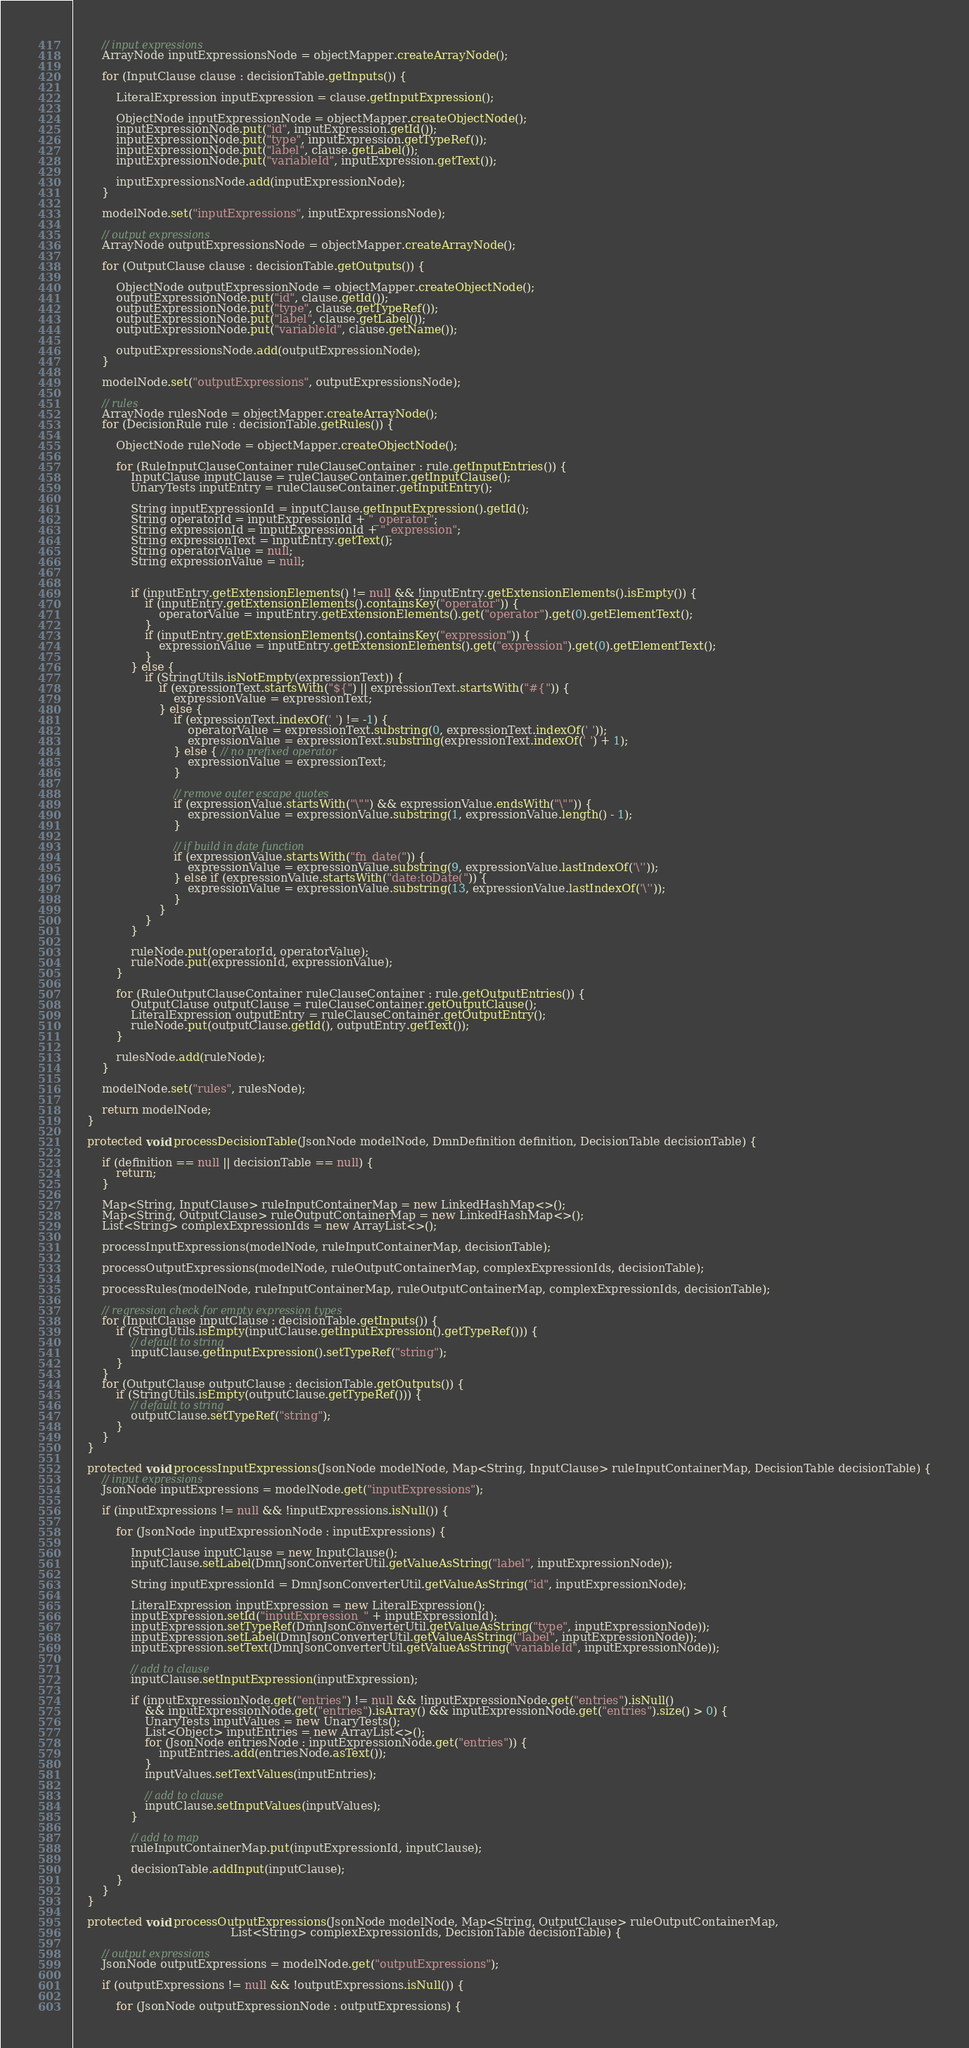<code> <loc_0><loc_0><loc_500><loc_500><_Java_>        // input expressions
        ArrayNode inputExpressionsNode = objectMapper.createArrayNode();

        for (InputClause clause : decisionTable.getInputs()) {

            LiteralExpression inputExpression = clause.getInputExpression();

            ObjectNode inputExpressionNode = objectMapper.createObjectNode();
            inputExpressionNode.put("id", inputExpression.getId());
            inputExpressionNode.put("type", inputExpression.getTypeRef());
            inputExpressionNode.put("label", clause.getLabel());
            inputExpressionNode.put("variableId", inputExpression.getText());

            inputExpressionsNode.add(inputExpressionNode);
        }

        modelNode.set("inputExpressions", inputExpressionsNode);

        // output expressions
        ArrayNode outputExpressionsNode = objectMapper.createArrayNode();

        for (OutputClause clause : decisionTable.getOutputs()) {

            ObjectNode outputExpressionNode = objectMapper.createObjectNode();
            outputExpressionNode.put("id", clause.getId());
            outputExpressionNode.put("type", clause.getTypeRef());
            outputExpressionNode.put("label", clause.getLabel());
            outputExpressionNode.put("variableId", clause.getName());

            outputExpressionsNode.add(outputExpressionNode);
        }

        modelNode.set("outputExpressions", outputExpressionsNode);

        // rules
        ArrayNode rulesNode = objectMapper.createArrayNode();
        for (DecisionRule rule : decisionTable.getRules()) {

            ObjectNode ruleNode = objectMapper.createObjectNode();

            for (RuleInputClauseContainer ruleClauseContainer : rule.getInputEntries()) {
                InputClause inputClause = ruleClauseContainer.getInputClause();
                UnaryTests inputEntry = ruleClauseContainer.getInputEntry();

                String inputExpressionId = inputClause.getInputExpression().getId();
                String operatorId = inputExpressionId + "_operator";
                String expressionId = inputExpressionId + "_expression";
                String expressionText = inputEntry.getText();
                String operatorValue = null;
                String expressionValue = null;


                if (inputEntry.getExtensionElements() != null && !inputEntry.getExtensionElements().isEmpty()) {
                    if (inputEntry.getExtensionElements().containsKey("operator")) {
                        operatorValue = inputEntry.getExtensionElements().get("operator").get(0).getElementText();
                    }
                    if (inputEntry.getExtensionElements().containsKey("expression")) {
                        expressionValue = inputEntry.getExtensionElements().get("expression").get(0).getElementText();
                    }
                } else {
                    if (StringUtils.isNotEmpty(expressionText)) {
                        if (expressionText.startsWith("${") || expressionText.startsWith("#{")) {
                            expressionValue = expressionText;
                        } else {
                            if (expressionText.indexOf(' ') != -1) {
                                operatorValue = expressionText.substring(0, expressionText.indexOf(' '));
                                expressionValue = expressionText.substring(expressionText.indexOf(' ') + 1);
                            } else { // no prefixed operator
                                expressionValue = expressionText;
                            }

                            // remove outer escape quotes
                            if (expressionValue.startsWith("\"") && expressionValue.endsWith("\"")) {
                                expressionValue = expressionValue.substring(1, expressionValue.length() - 1);
                            }

                            // if build in date function
                            if (expressionValue.startsWith("fn_date(")) {
                                expressionValue = expressionValue.substring(9, expressionValue.lastIndexOf('\''));
                            } else if (expressionValue.startsWith("date:toDate(")) {
                                expressionValue = expressionValue.substring(13, expressionValue.lastIndexOf('\''));
                            }
                        }
                    }
                }

                ruleNode.put(operatorId, operatorValue);
                ruleNode.put(expressionId, expressionValue);
            }

            for (RuleOutputClauseContainer ruleClauseContainer : rule.getOutputEntries()) {
                OutputClause outputClause = ruleClauseContainer.getOutputClause();
                LiteralExpression outputEntry = ruleClauseContainer.getOutputEntry();
                ruleNode.put(outputClause.getId(), outputEntry.getText());
            }

            rulesNode.add(ruleNode);
        }

        modelNode.set("rules", rulesNode);

        return modelNode;
    }

    protected void processDecisionTable(JsonNode modelNode, DmnDefinition definition, DecisionTable decisionTable) {

        if (definition == null || decisionTable == null) {
            return;
        }

        Map<String, InputClause> ruleInputContainerMap = new LinkedHashMap<>();
        Map<String, OutputClause> ruleOutputContainerMap = new LinkedHashMap<>();
        List<String> complexExpressionIds = new ArrayList<>();

        processInputExpressions(modelNode, ruleInputContainerMap, decisionTable);

        processOutputExpressions(modelNode, ruleOutputContainerMap, complexExpressionIds, decisionTable);

        processRules(modelNode, ruleInputContainerMap, ruleOutputContainerMap, complexExpressionIds, decisionTable);

        // regression check for empty expression types
        for (InputClause inputClause : decisionTable.getInputs()) {
            if (StringUtils.isEmpty(inputClause.getInputExpression().getTypeRef())) {
                // default to string
                inputClause.getInputExpression().setTypeRef("string");
            }
        }
        for (OutputClause outputClause : decisionTable.getOutputs()) {
            if (StringUtils.isEmpty(outputClause.getTypeRef())) {
                // default to string
                outputClause.setTypeRef("string");
            }
        }
    }

    protected void processInputExpressions(JsonNode modelNode, Map<String, InputClause> ruleInputContainerMap, DecisionTable decisionTable) {
        // input expressions
        JsonNode inputExpressions = modelNode.get("inputExpressions");

        if (inputExpressions != null && !inputExpressions.isNull()) {

            for (JsonNode inputExpressionNode : inputExpressions) {

                InputClause inputClause = new InputClause();
                inputClause.setLabel(DmnJsonConverterUtil.getValueAsString("label", inputExpressionNode));

                String inputExpressionId = DmnJsonConverterUtil.getValueAsString("id", inputExpressionNode);

                LiteralExpression inputExpression = new LiteralExpression();
                inputExpression.setId("inputExpression_" + inputExpressionId);
                inputExpression.setTypeRef(DmnJsonConverterUtil.getValueAsString("type", inputExpressionNode));
                inputExpression.setLabel(DmnJsonConverterUtil.getValueAsString("label", inputExpressionNode));
                inputExpression.setText(DmnJsonConverterUtil.getValueAsString("variableId", inputExpressionNode));

                // add to clause
                inputClause.setInputExpression(inputExpression);

                if (inputExpressionNode.get("entries") != null && !inputExpressionNode.get("entries").isNull()
                    && inputExpressionNode.get("entries").isArray() && inputExpressionNode.get("entries").size() > 0) {
                    UnaryTests inputValues = new UnaryTests();
                    List<Object> inputEntries = new ArrayList<>();
                    for (JsonNode entriesNode : inputExpressionNode.get("entries")) {
                        inputEntries.add(entriesNode.asText());
                    }
                    inputValues.setTextValues(inputEntries);

                    // add to clause
                    inputClause.setInputValues(inputValues);
                }

                // add to map
                ruleInputContainerMap.put(inputExpressionId, inputClause);

                decisionTable.addInput(inputClause);
            }
        }
    }

    protected void processOutputExpressions(JsonNode modelNode, Map<String, OutputClause> ruleOutputContainerMap,
                                            List<String> complexExpressionIds, DecisionTable decisionTable) {

        // output expressions
        JsonNode outputExpressions = modelNode.get("outputExpressions");

        if (outputExpressions != null && !outputExpressions.isNull()) {

            for (JsonNode outputExpressionNode : outputExpressions) {
</code> 